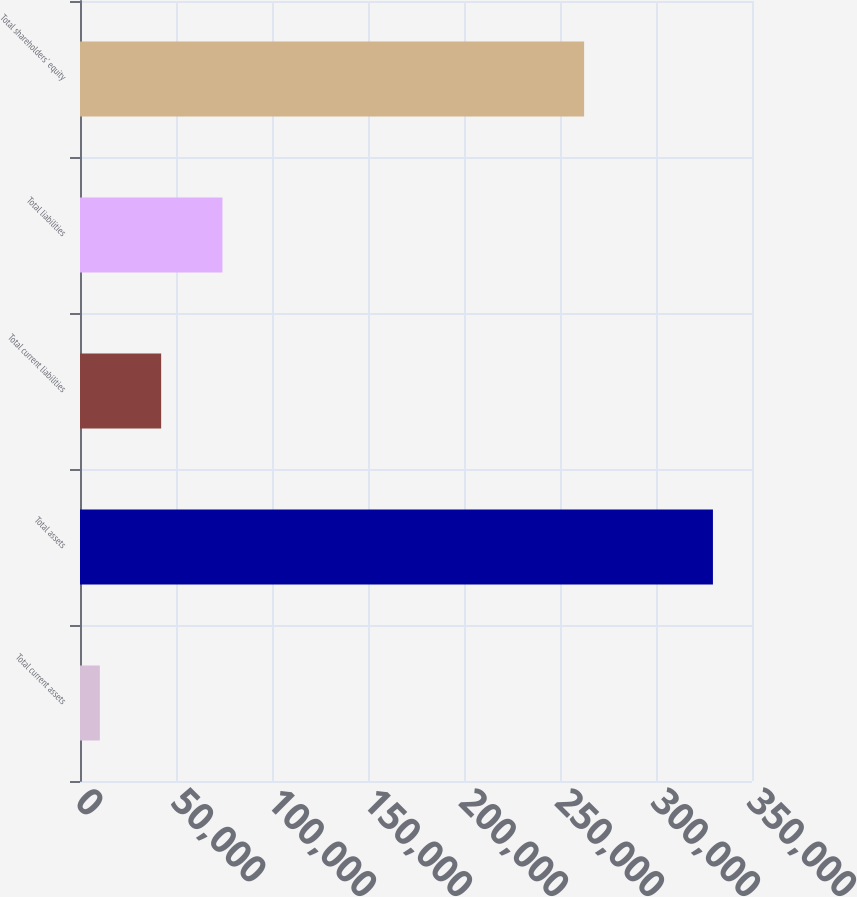Convert chart to OTSL. <chart><loc_0><loc_0><loc_500><loc_500><bar_chart><fcel>Total current assets<fcel>Total assets<fcel>Total current liabilities<fcel>Total liabilities<fcel>Total shareholders' equity<nl><fcel>10332<fcel>329653<fcel>42264.1<fcel>74196.2<fcel>262566<nl></chart> 